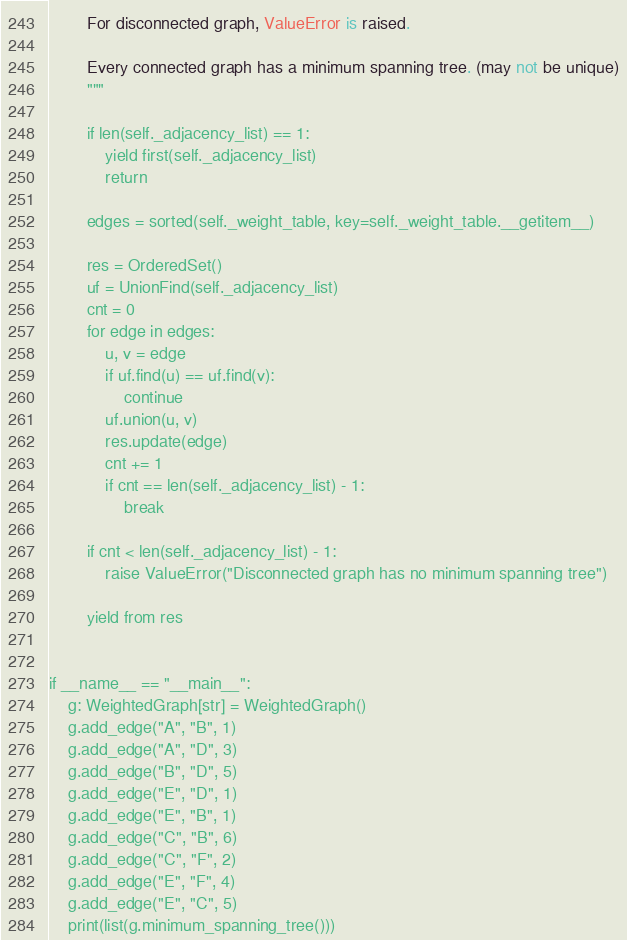<code> <loc_0><loc_0><loc_500><loc_500><_Python_>
        For disconnected graph, ValueError is raised.

        Every connected graph has a minimum spanning tree. (may not be unique)
        """

        if len(self._adjacency_list) == 1:
            yield first(self._adjacency_list)
            return

        edges = sorted(self._weight_table, key=self._weight_table.__getitem__)

        res = OrderedSet()
        uf = UnionFind(self._adjacency_list)
        cnt = 0
        for edge in edges:
            u, v = edge
            if uf.find(u) == uf.find(v):
                continue
            uf.union(u, v)
            res.update(edge)
            cnt += 1
            if cnt == len(self._adjacency_list) - 1:
                break

        if cnt < len(self._adjacency_list) - 1:
            raise ValueError("Disconnected graph has no minimum spanning tree")

        yield from res


if __name__ == "__main__":
    g: WeightedGraph[str] = WeightedGraph()
    g.add_edge("A", "B", 1)
    g.add_edge("A", "D", 3)
    g.add_edge("B", "D", 5)
    g.add_edge("E", "D", 1)
    g.add_edge("E", "B", 1)
    g.add_edge("C", "B", 6)
    g.add_edge("C", "F", 2)
    g.add_edge("E", "F", 4)
    g.add_edge("E", "C", 5)
    print(list(g.minimum_spanning_tree()))
</code> 